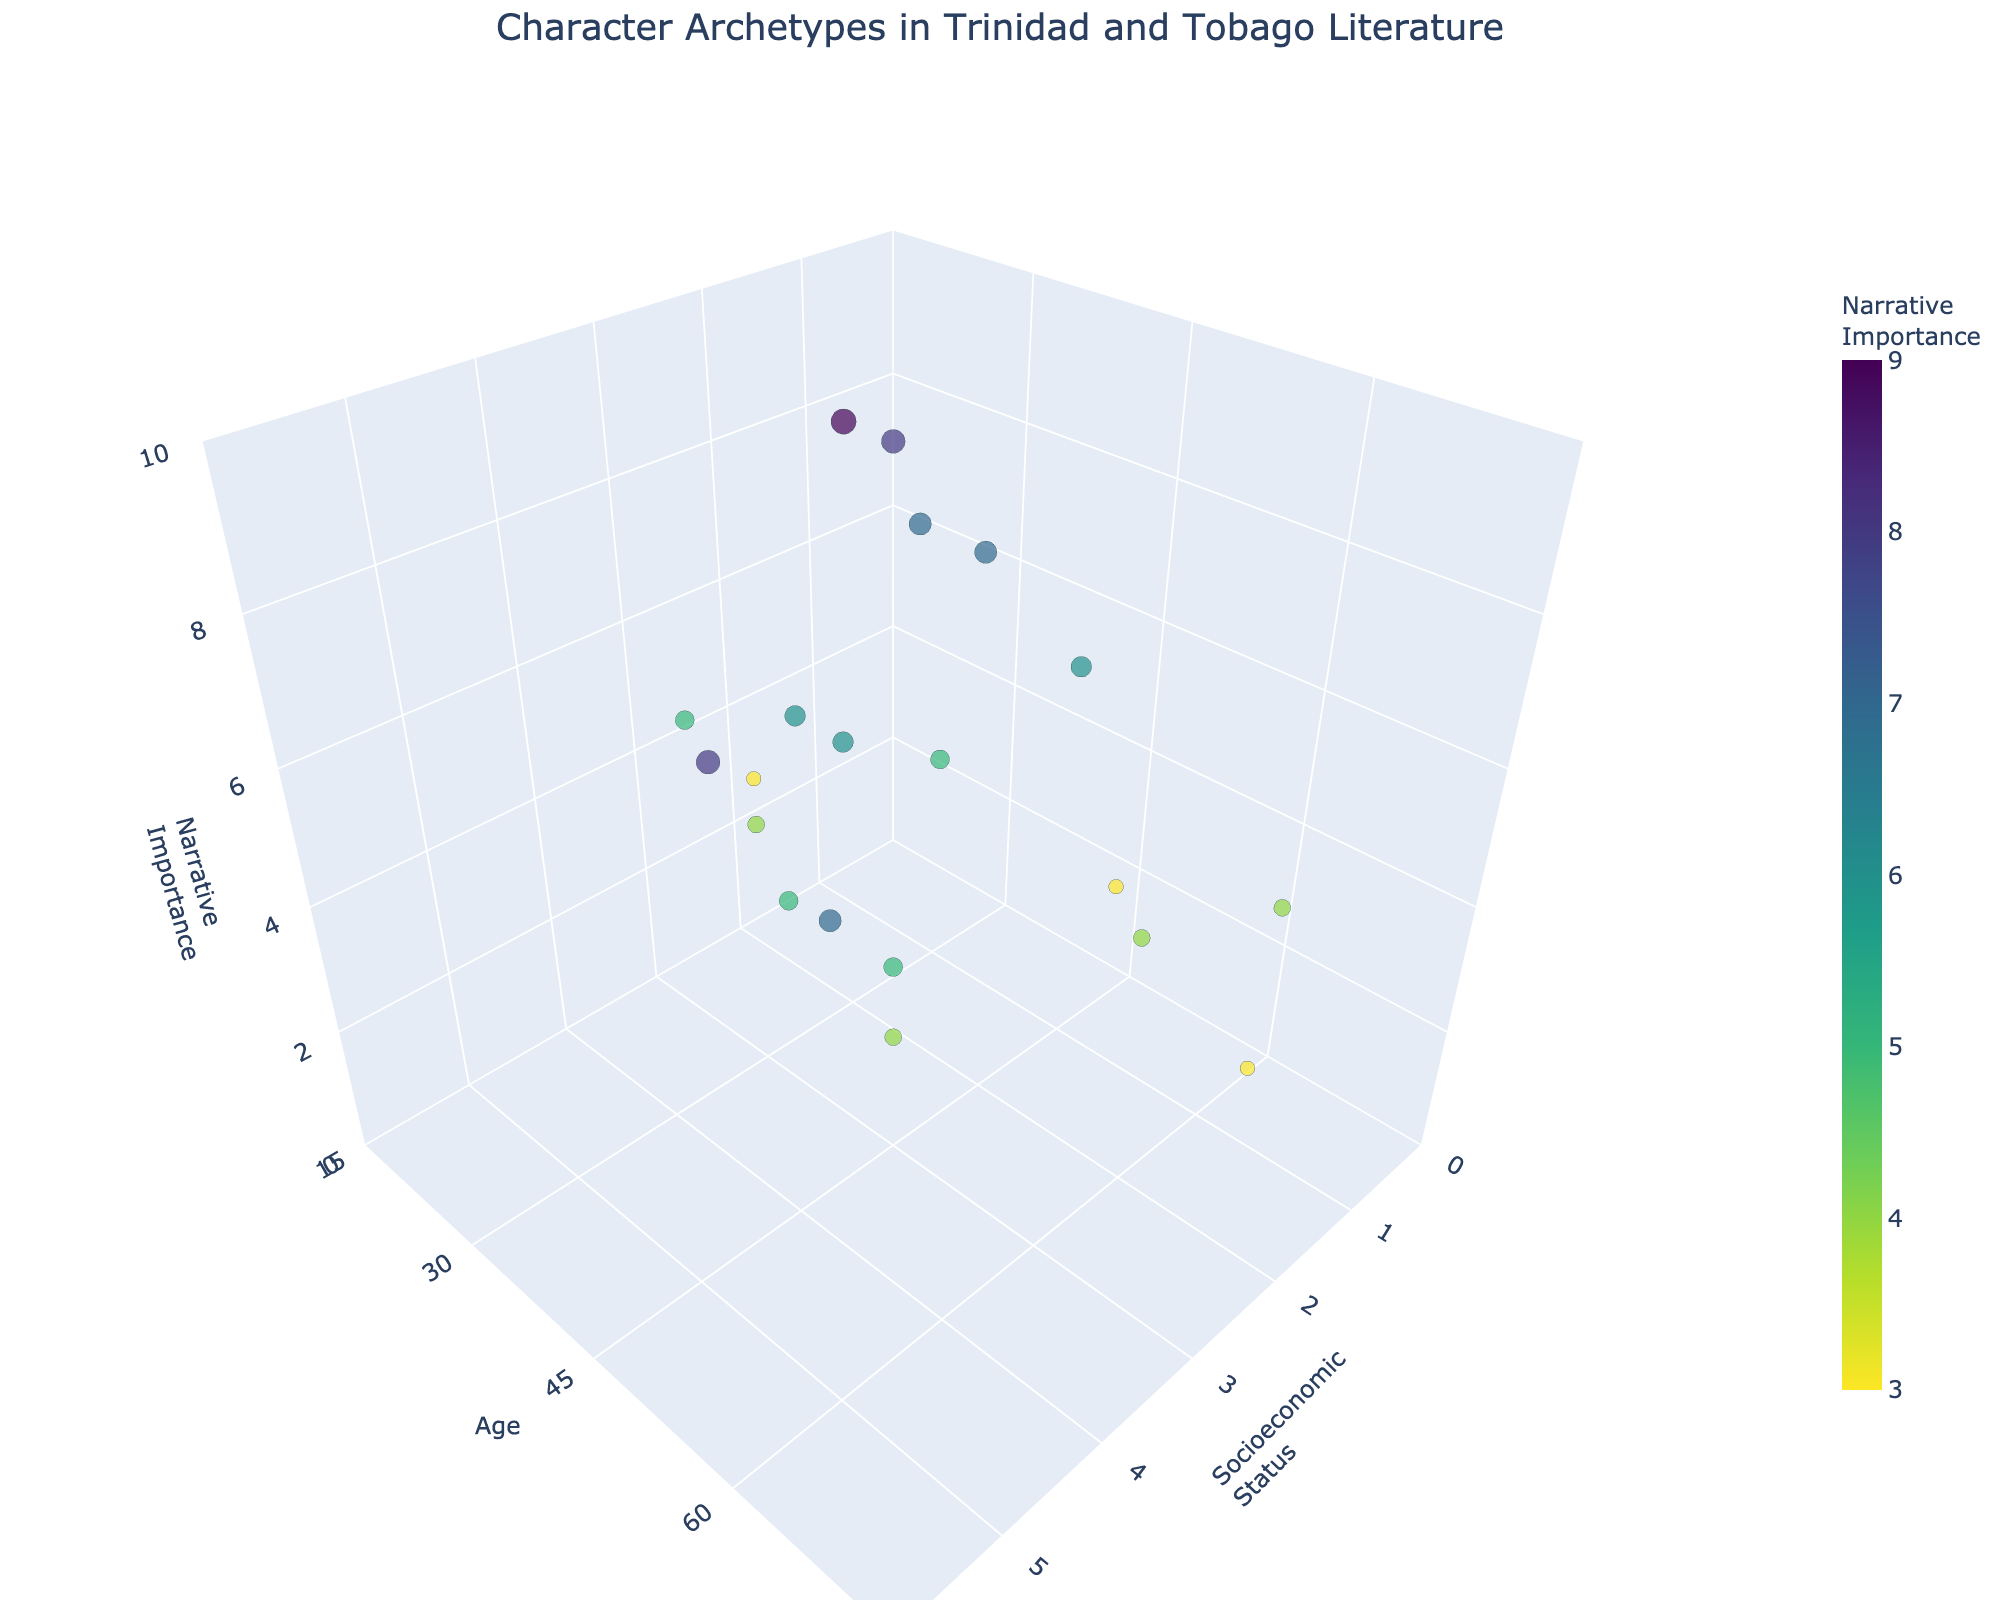What is the narrative importance of Ivan Morton? Ivan Morton’s narrative importance can be found by locating his data point and checking the 'Narrative Importance' axis.
Answer: 8 How many characters have a socioeconomic status of 1? To determine this, count the number of data points that align with a 'Socioeconomic Status' of 1 on the x-axis.
Answer: 6 Which character is the oldest? Identify the character with the highest value on the 'Age' axis, which represents their age.
Answer: Miss Caroline What is the average age of characters with a narrative importance of 7? To calculate the average, first identify characters with a narrative importance of 7 (Fisheye, Pariag, and Alford George). Their ages are 35, 28, and 60 respectively. Calculate the average: (35 + 28 + 60) / 3.
Answer: 41 Who has a higher narrative importance, Sylvia or Bee Dorcas? Compare the 'Narrative Importance' values of Sylvia (8) and Bee Dorcas (4) by looking at their positions along the 'Narrative Importance' axis.
Answer: Sylvia What is the range of ages for characters with a socioeconomic status of 2? Locate characters with a socioeconomic status of 2, identify their ages (Aldrick, Miss Olive, Miss Caroline, Taffy, and Sophie: 30, 60, 70, 18, and 40 respectively). Calculate the range: 70 - 18.
Answer: 52 Which character with a socioeconomic status of 4 has the highest narrative importance? Find characters with a socioeconomic status of 4 and compare their narrative importance values. Cleothilda (5), Walter Castle (5), and Mervyn Edghill (4).
Answer: Cleothilda or Walter Castle What is the average narrative importance of characters older than 50? Identify characters older than 50 (Miss Olive, Miss Caroline, Alford George, Kangkala, Cleothilda, Ivan Morton, Primus, and Mervyn Edghill). Their narrative importance values are (4, 3, 7, 4, 5, 8, 3, and 4). Calculate the average: (4 + 3 + 7 + 4 + 5 + 8 + 3 + 4) / 8.
Answer: 4.75 